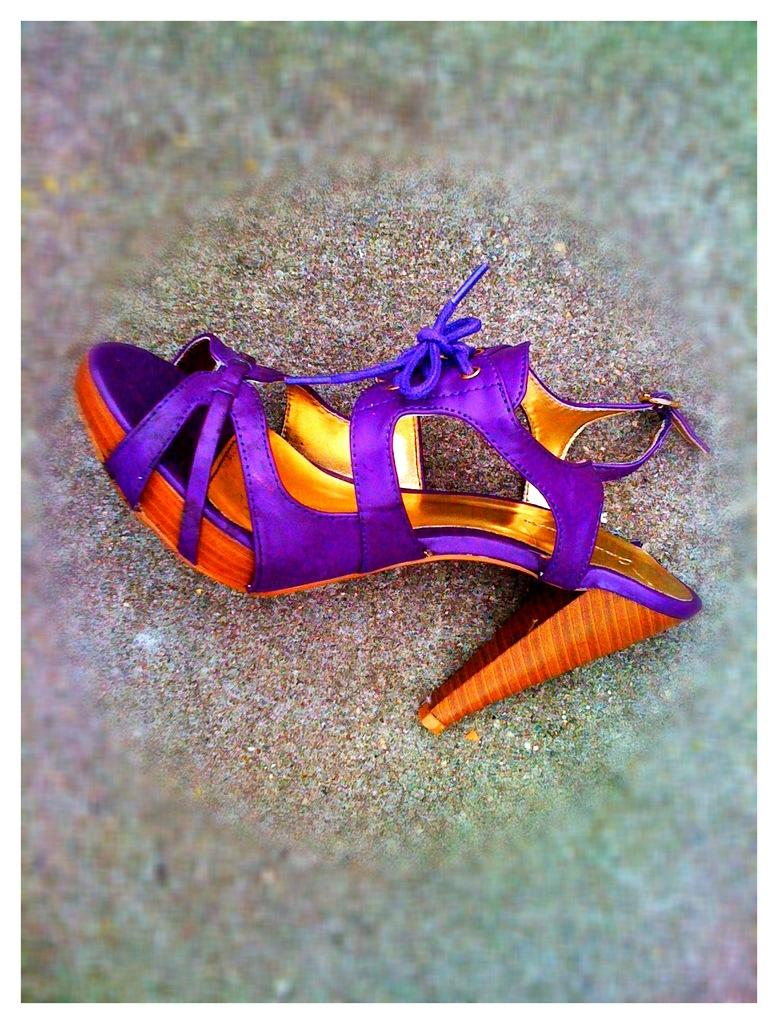What type of footwear is depicted in the image? There is a heel on the ground in the image. What features can be seen on the heel? The heel has laces and a buckle. How would you describe the overall appearance of the image? The edges of the image are blurry. How many bikes are parked next to the heel in the image? There are no bikes present in the image; it only features a heel on the ground. What type of fruit is placed in the basin next to the heel in the image? There is no basin or fruit present in the image; it only features a heel on the ground. 